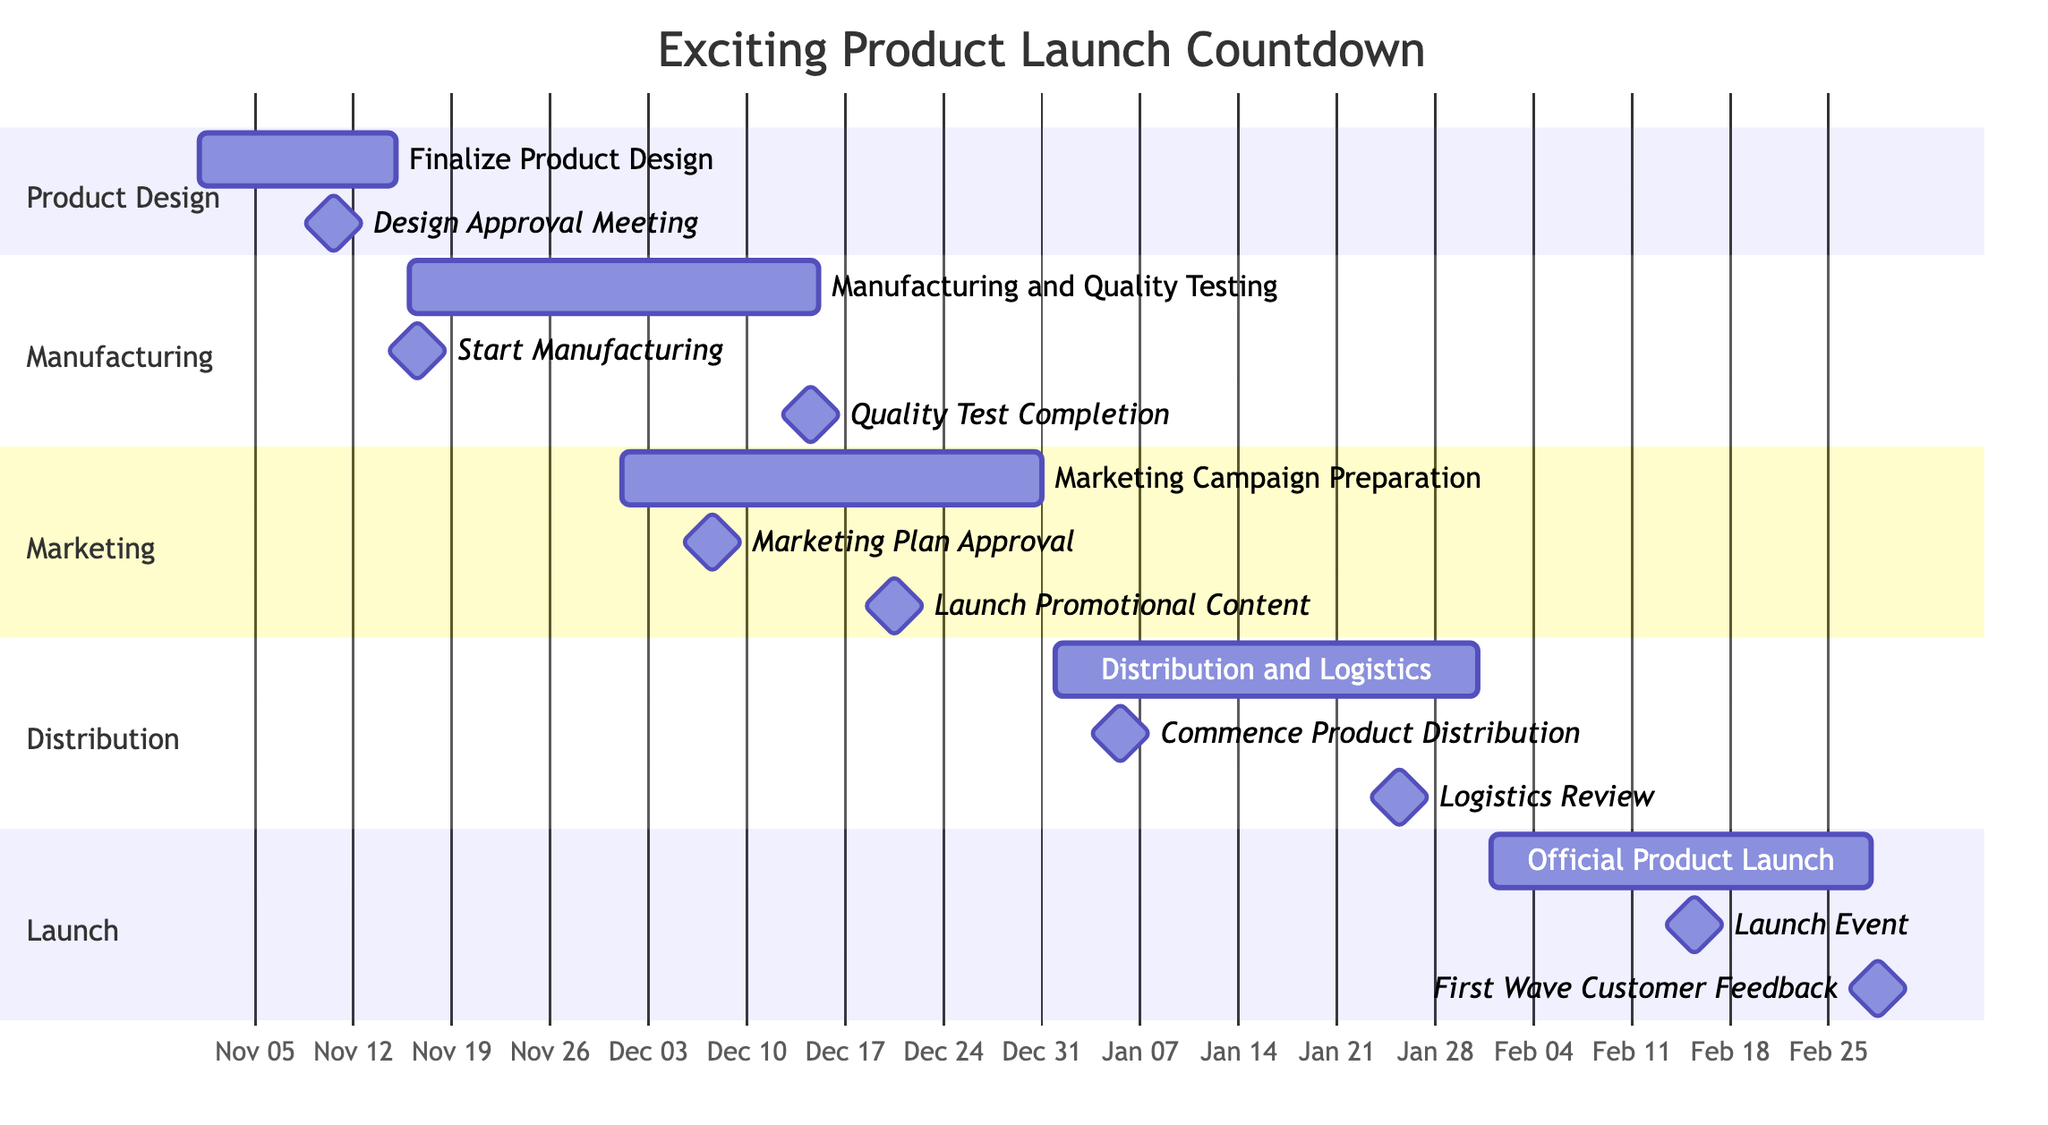What is the start date of the project? The start date of the project, as shown in the diagram's title, is listed as November 1, 2023.
Answer: November 1, 2023 How many milestones are associated with the task "Manufacturing and Quality Testing"? There are two milestones listed under the "Manufacturing and Quality Testing" task in the diagram: "Start Manufacturing" and "Quality Test Completion."
Answer: 2 What is the end date of the "Marketing Campaign Preparation" task? The end date for the "Marketing Campaign Preparation" task is specified from the diagram as December 31, 2023.
Answer: December 31, 2023 Which milestone is scheduled for December 14, 2023? The milestone that is scheduled for December 14, 2023, is "Quality Test Completion," as indicated in the milestones of the manufacturing section.
Answer: Quality Test Completion Which task starts immediately after the "Finalize Product Design"? According to the timeline, the task that begins right after "Finalize Product Design" is "Manufacturing and Quality Testing" on November 16, 2023.
Answer: Manufacturing and Quality Testing How many total sections are in the Gantt chart? The Gantt chart consists of five sections: Product Design, Manufacturing, Marketing, Distribution, and Launch, as visually segmented in the diagram.
Answer: 5 What is the milestone date for the "Launch Event"? The "Launch Event" milestone is set for February 15, 2024, as seen in the Launch section of the diagram.
Answer: February 15, 2024 When does the "Distribution and Logistics" task start? The "Distribution and Logistics" task starts on January 1, 2024, according to the timeline constructed in the Gantt chart.
Answer: January 1, 2024 What are the key milestones for the "Official Product Launch"? The key milestones for "Official Product Launch" are "Launch Event" on February 15, 2024, and "First Wave Customer Feedback" on February 28, 2024. These are the essential checkpoints listed under this task in the diagram.
Answer: Launch Event, First Wave Customer Feedback 